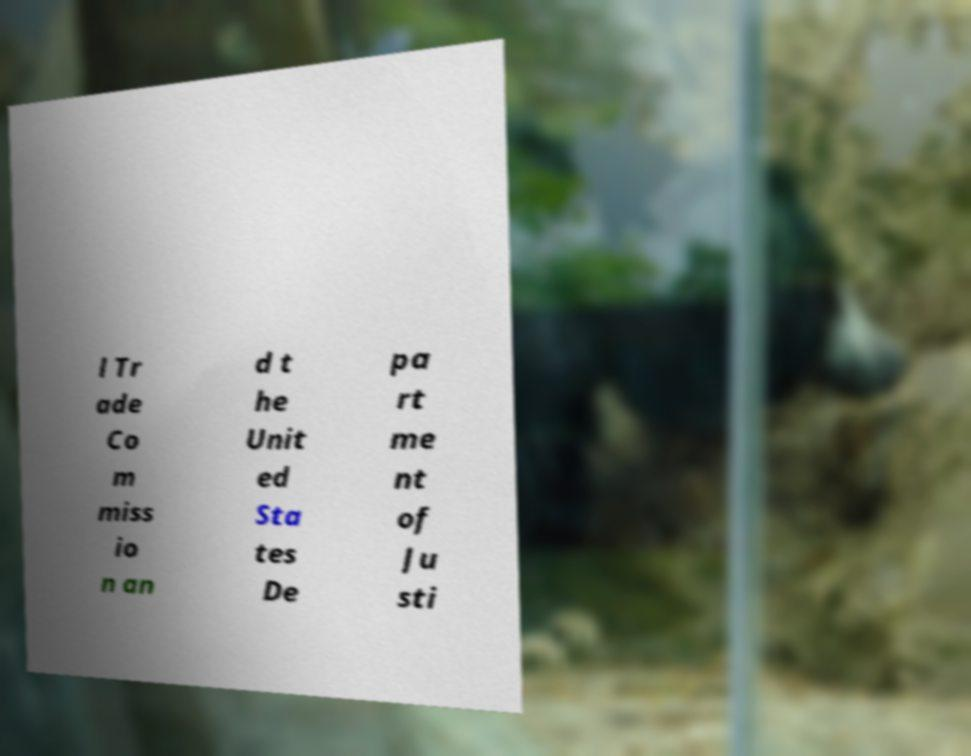Could you extract and type out the text from this image? l Tr ade Co m miss io n an d t he Unit ed Sta tes De pa rt me nt of Ju sti 